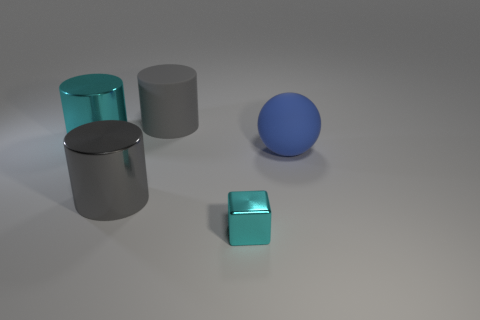Add 3 matte cylinders. How many objects exist? 8 Subtract all cylinders. How many objects are left? 2 Add 5 cyan cylinders. How many cyan cylinders exist? 6 Subtract 0 gray cubes. How many objects are left? 5 Subtract all large purple balls. Subtract all tiny cyan shiny objects. How many objects are left? 4 Add 1 cyan shiny blocks. How many cyan shiny blocks are left? 2 